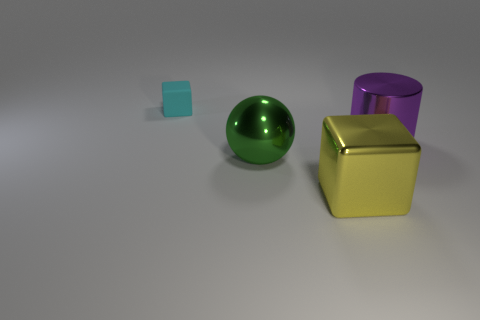Subtract all cyan cubes. How many cubes are left? 1 Subtract 2 cubes. How many cubes are left? 0 Subtract all cylinders. How many objects are left? 3 Add 4 tiny rubber objects. How many objects exist? 8 Add 2 big cubes. How many big cubes are left? 3 Add 4 spheres. How many spheres exist? 5 Subtract 1 yellow blocks. How many objects are left? 3 Subtract all green cylinders. Subtract all blue cubes. How many cylinders are left? 1 Subtract all small red matte balls. Subtract all large purple cylinders. How many objects are left? 3 